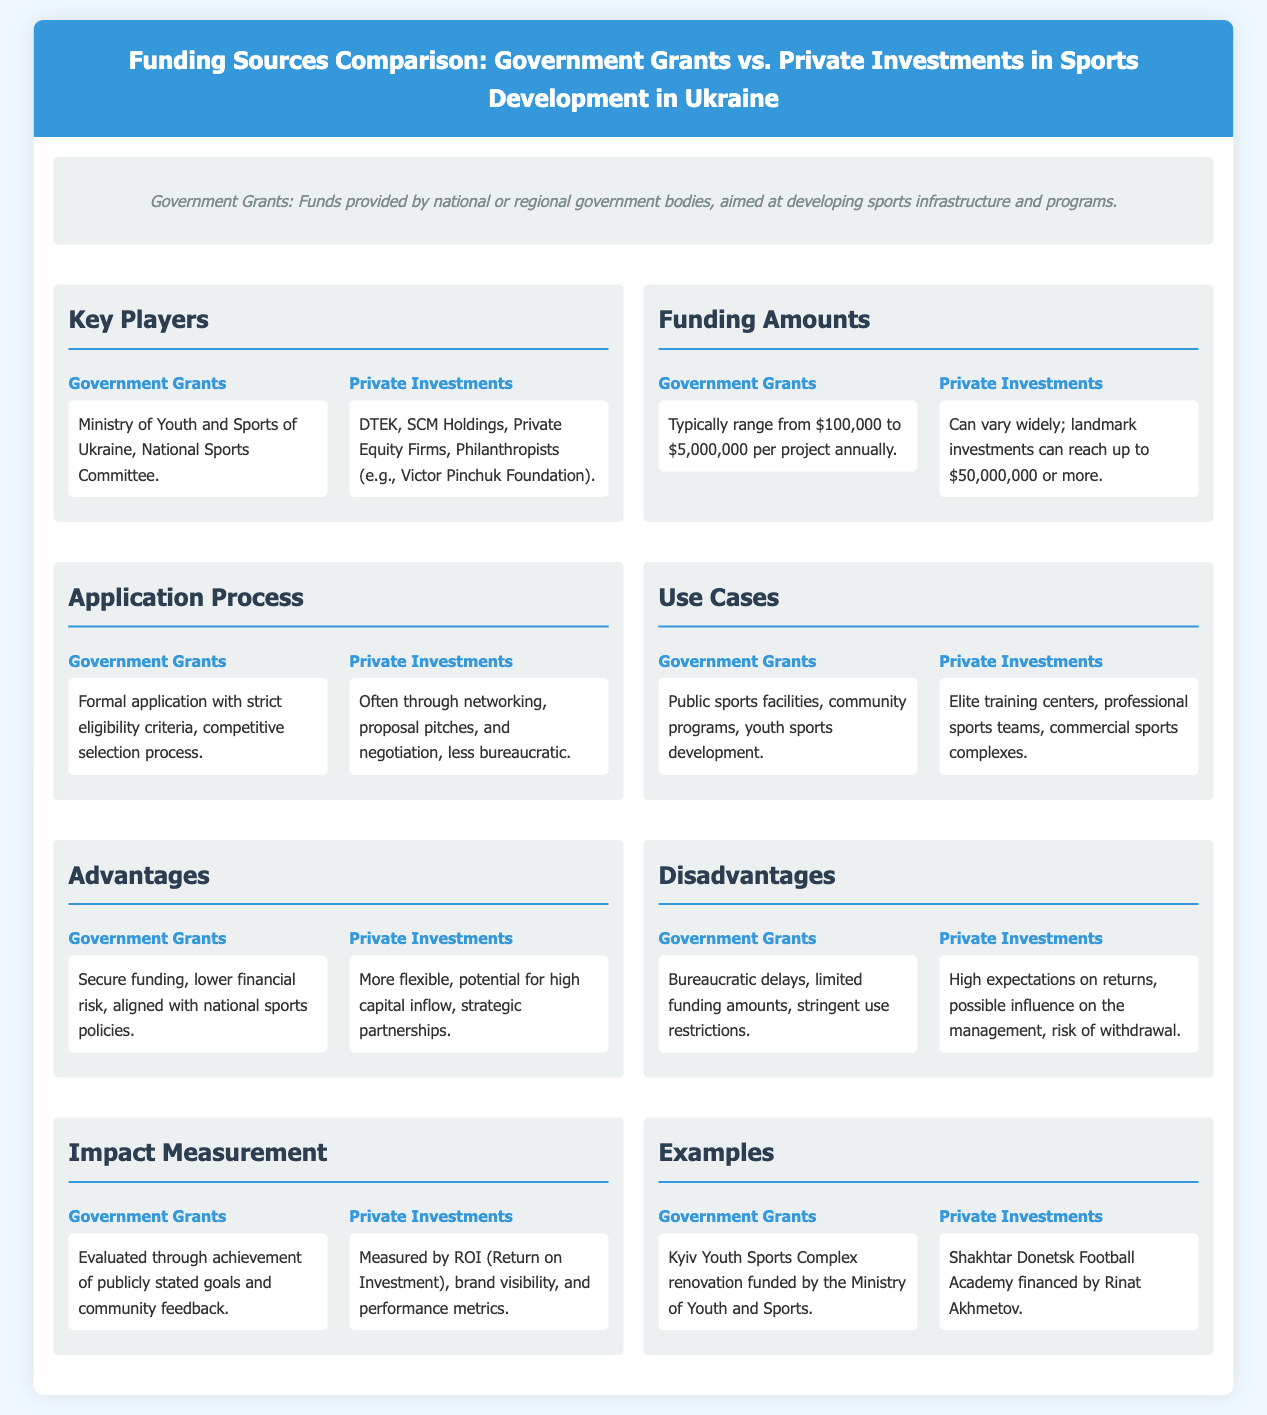What are the key players for Government Grants? The key players mentioned in the document for Government Grants include the Ministry of Youth and Sports of Ukraine and the National Sports Committee.
Answer: Ministry of Youth and Sports of Ukraine, National Sports Committee What is the funding range for Government Grants? The document states that Government Grants typically range from $100,000 to $5,000,000 per project annually.
Answer: $100,000 to $5,000,000 What advantages do Government Grants offer? The advantages of Government Grants include secure funding, lower financial risk, and alignment with national sports policies.
Answer: Secure funding, lower financial risk, aligned with national sports policies What is the application process for Private Investments? The document indicates that Private Investments often involve networking, proposal pitches, and negotiation, with less bureaucracy.
Answer: Networking, proposal pitches, negotiation What is one use case for Government Grants? According to the document, one use case for Government Grants is the funding of public sports facilities.
Answer: Public sports facilities Which type of investment can reach landmark amounts of $50,000,000 or more? The document specifies that Private Investments can vary widely and can reach landmark amounts of up to $50,000,000.
Answer: Private Investments What are the disadvantages of Private Investments? The disadvantages mentioned for Private Investments include high expectations on returns and the risk of withdrawal.
Answer: High expectations on returns, risk of withdrawal How is the impact of Government Grants measured? The document states that the impact of Government Grants is evaluated through the achievement of publicly stated goals and community feedback.
Answer: Achievement of publicly stated goals and community feedback 